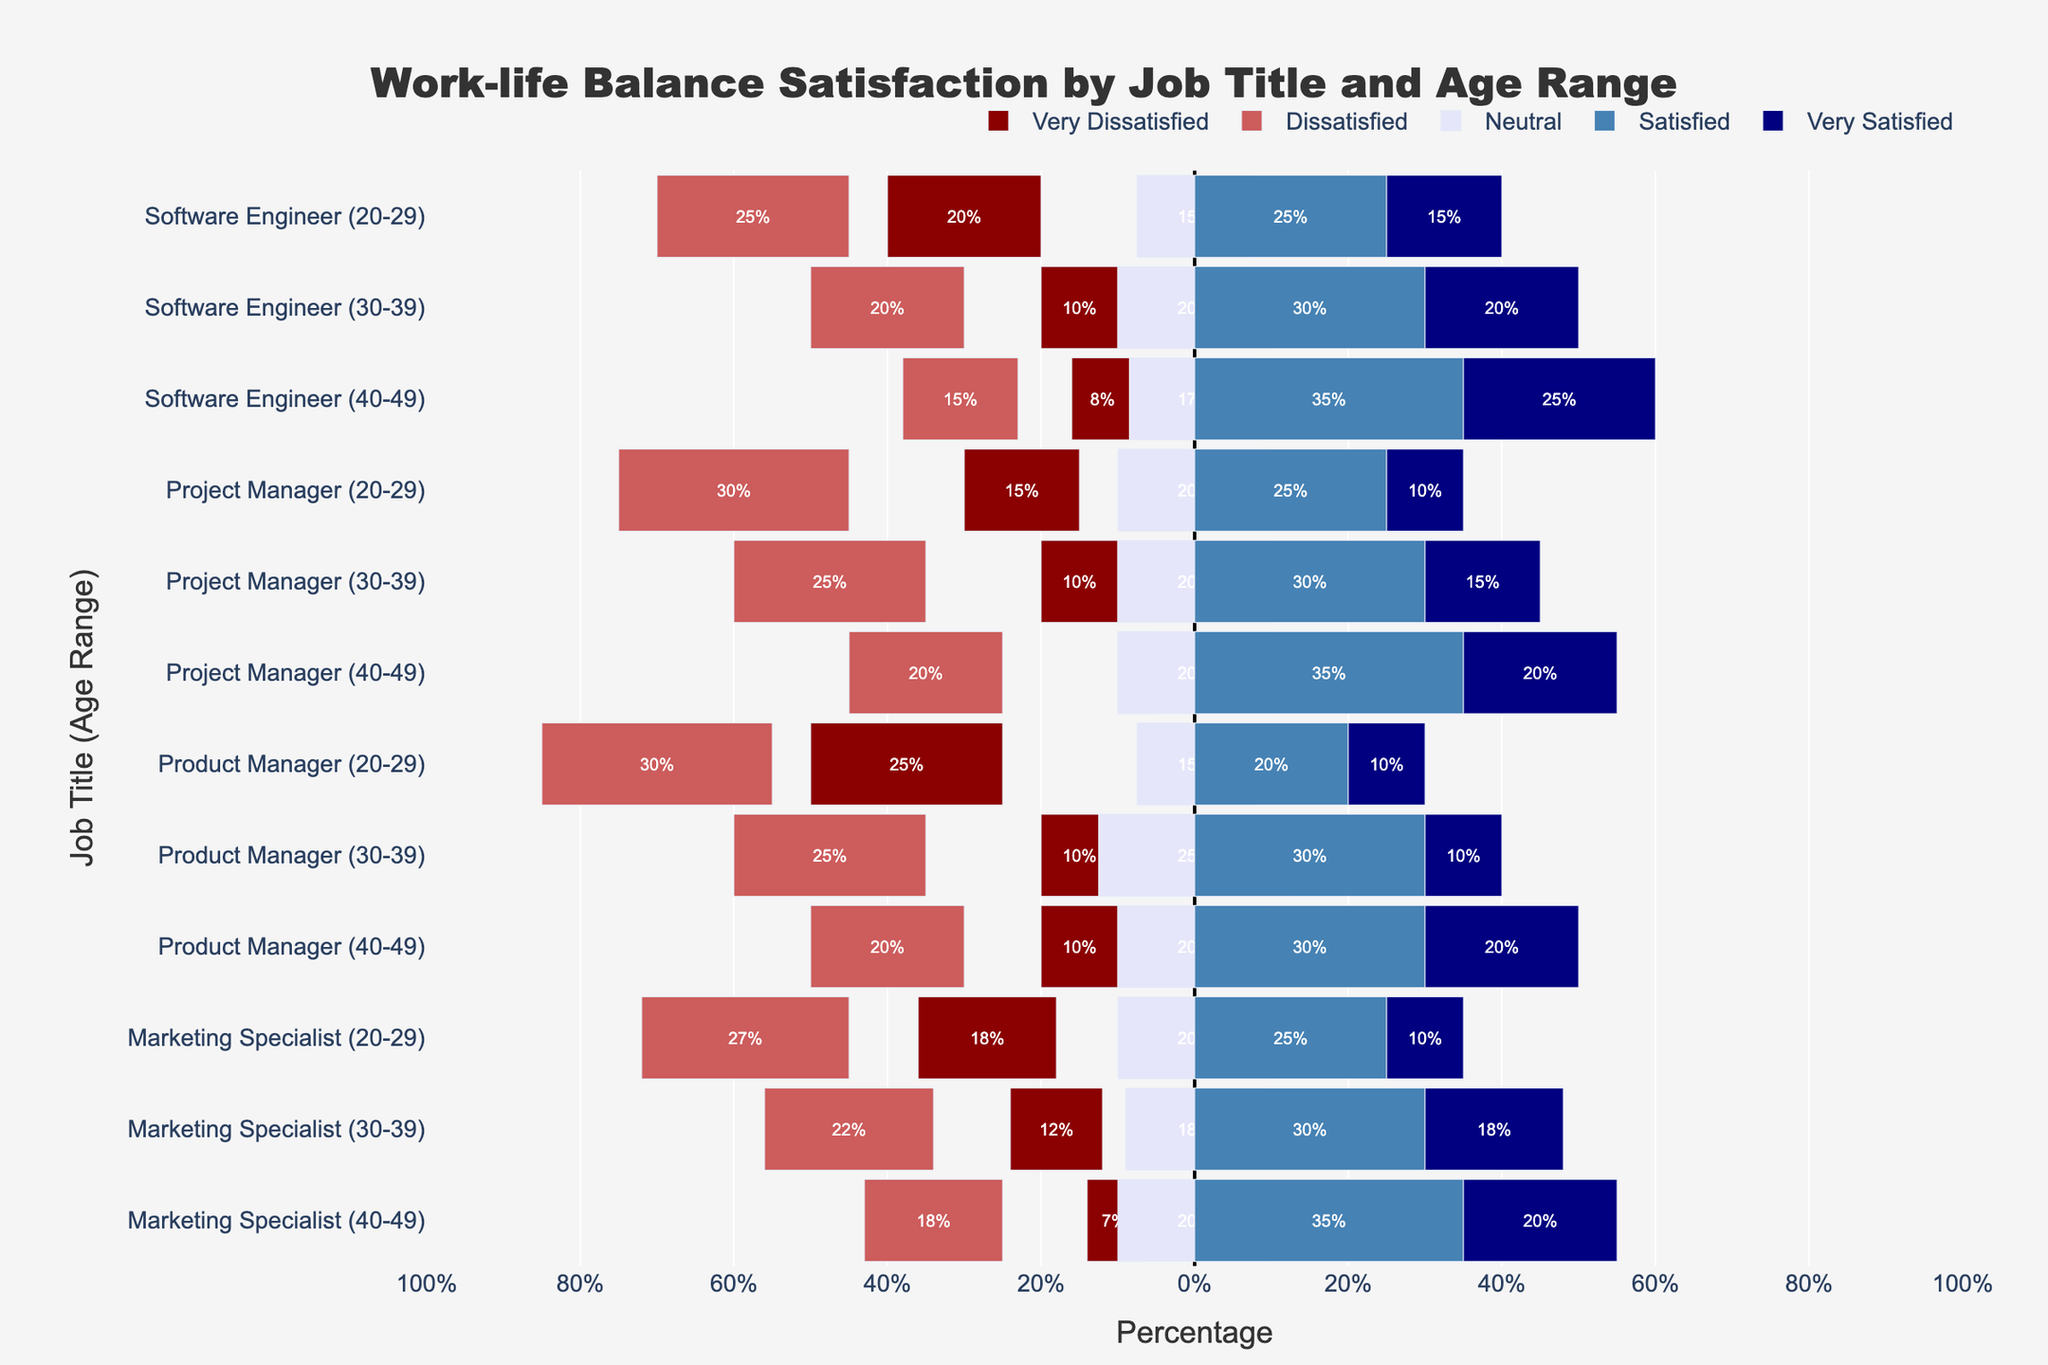What is the highest percentage of "Very Satisfied" respondents across all job titles and age ranges? Looking at the 'Very Satisfied' section in the chart, the largest value is for Software Engineers in the 40-49 age range with a 'Very Satisfied' percentage of 25%.
Answer: 25% Which job title and age range has the highest combined dissatisfaction (Very Dissatisfied + Dissatisfied)? Combining the 'Very Dissatisfied' and 'Dissatisfied' percentages, the highest total dissatisfaction is for Product Managers in the 20-29 age range with 25% + 30% = 55%.
Answer: Product Managers (20-29) Which group has more "Satisfied" respondents: Project Managers aged 30-39 or Marketing Specialists aged 40-49? Comparing the 'Satisfied' percentages, Project Managers aged 30-39 have 30%, whereas Marketing Specialists aged 40-49 have 35%, so Marketing Specialists aged 40-49 have more 'Satisfied' respondents.
Answer: Marketing Specialists (40-49) What is the total percentage of 'Neutral' and 'Satisfied' respondents for Software Engineers aged 30-39? Adding the 'Neutral' and 'Satisfied' percentages for this group: 20% + 30% = 50%.
Answer: 50% Which job title and age range has the least "Very Dissatisfied" respondents? The lowest 'Very Dissatisfied' percentage is shared by Project Managers aged 40-49 and Software Engineers aged 40-49, both with 5%.
Answer: Project Managers (40-49), Software Engineers (40-49) Compare the percentage of "Very Dissatisfied" respondents between Software Engineers aged 20-29 and Product Managers aged 20-29. Which group is higher, and by how much? Software Engineers aged 20-29 have 20% 'Very Dissatisfied', while Product Managers aged 20-29 have 25%. The difference is 5%.
Answer: Product Managers (20-29) by 5% Which job title and age range has the most 'Neutral' respondents? The highest 'Neutral' percentage is held by Product Managers aged 30-39 with 25%.
Answer: Product Managers (30-39) Are "Satisfied" respondents generally increasing or decreasing with age for Software Engineers? Observing the 'Satisfied' percentages for Software Engineers across age ranges: 25% (20-29), 30% (30-39), and 35% (40-49), this indicates an increasing trend with age.
Answer: Increasing What is the combined percentage of 'Very Satisfied' and 'Satisfied' respondents for Marketing Specialists aged 30-39? Adding the 'Very Satisfied' and 'Satisfied' percentages: 18% + 30% = 48%.
Answer: 48% Which has more 'Dissatisfied' respondents: Product Managers aged 30-39 or Project Managers aged 30-39? Comparing the 'Dissatisfied' percentages: Product Managers aged 30-39 have 25%, and Project Managers aged 30-39 have 25%.
Answer: Equal 